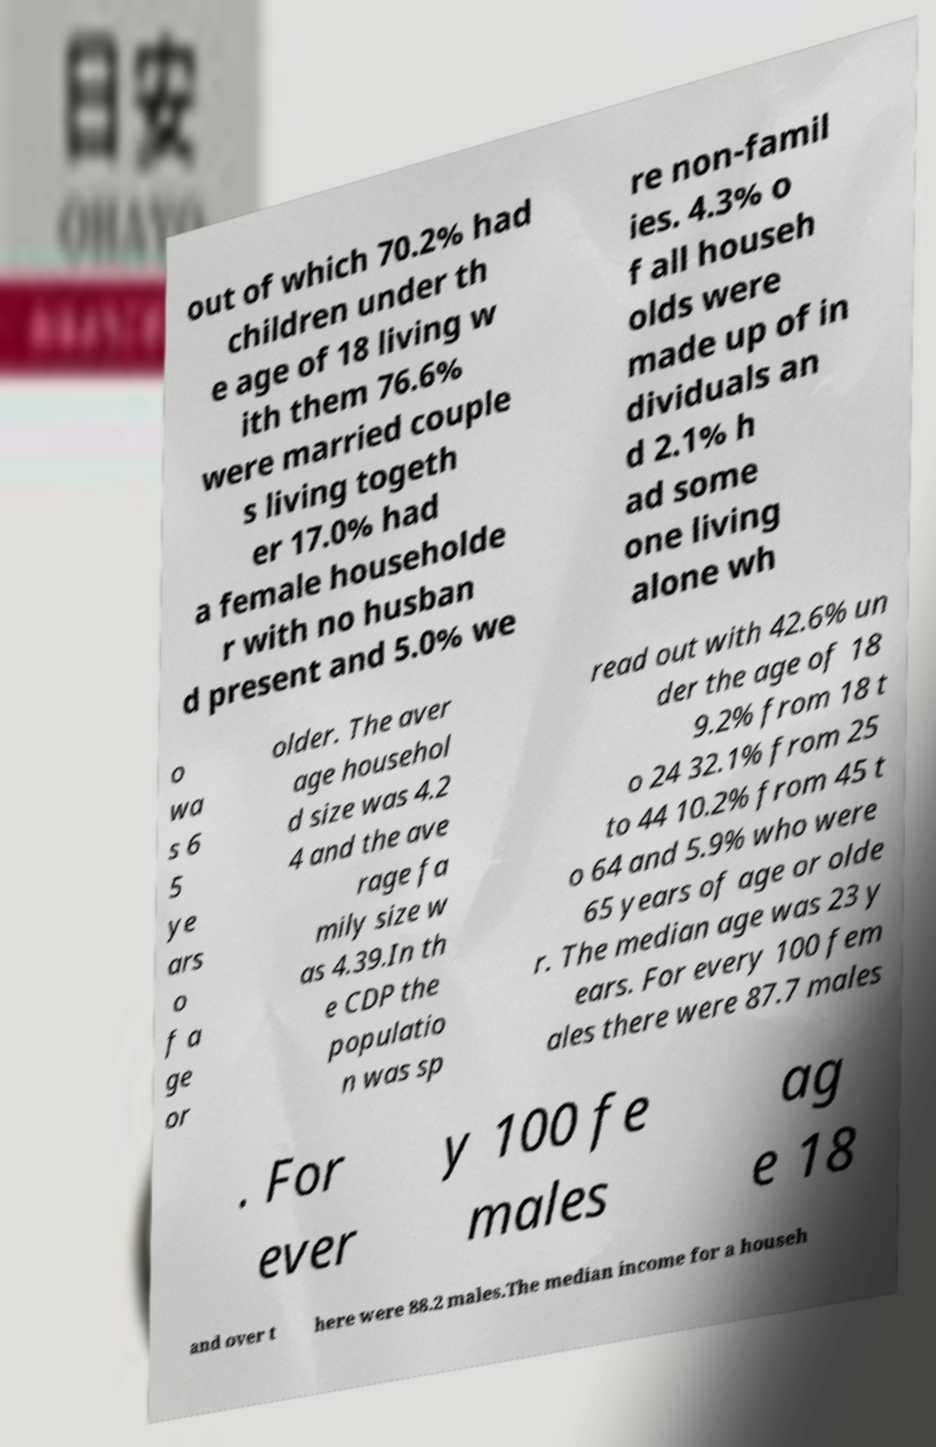Please identify and transcribe the text found in this image. out of which 70.2% had children under th e age of 18 living w ith them 76.6% were married couple s living togeth er 17.0% had a female householde r with no husban d present and 5.0% we re non-famil ies. 4.3% o f all househ olds were made up of in dividuals an d 2.1% h ad some one living alone wh o wa s 6 5 ye ars o f a ge or older. The aver age househol d size was 4.2 4 and the ave rage fa mily size w as 4.39.In th e CDP the populatio n was sp read out with 42.6% un der the age of 18 9.2% from 18 t o 24 32.1% from 25 to 44 10.2% from 45 t o 64 and 5.9% who were 65 years of age or olde r. The median age was 23 y ears. For every 100 fem ales there were 87.7 males . For ever y 100 fe males ag e 18 and over t here were 88.2 males.The median income for a househ 